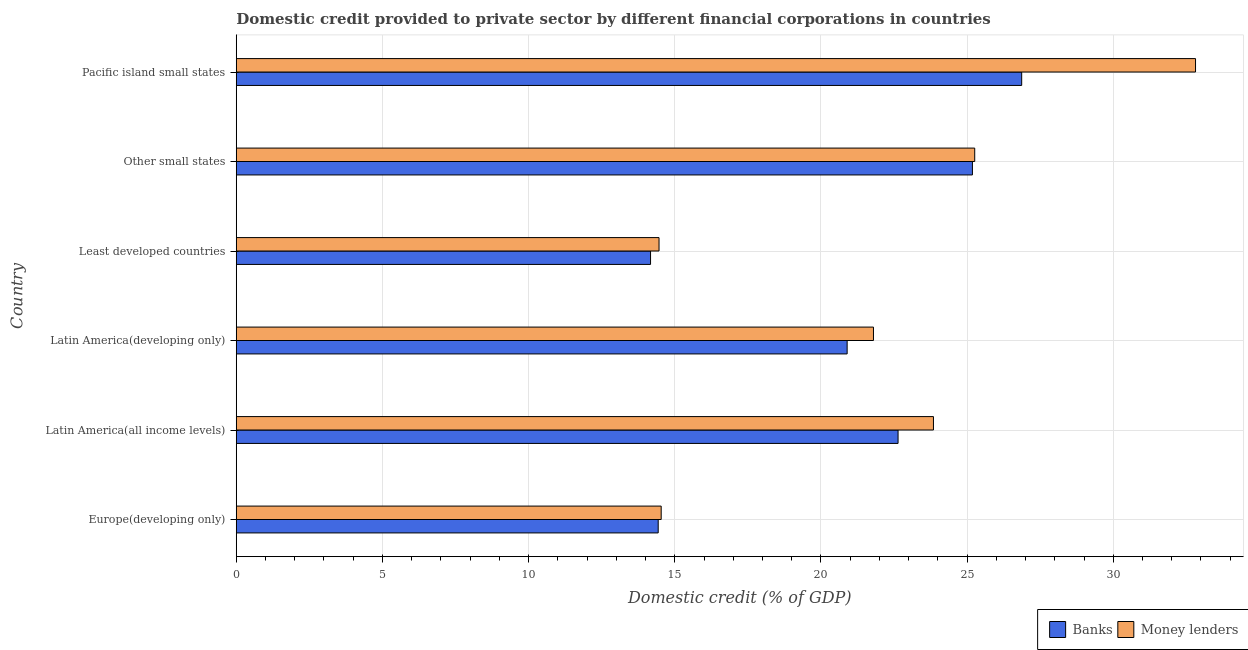How many different coloured bars are there?
Make the answer very short. 2. How many groups of bars are there?
Give a very brief answer. 6. Are the number of bars on each tick of the Y-axis equal?
Ensure brevity in your answer.  Yes. How many bars are there on the 3rd tick from the top?
Offer a very short reply. 2. What is the label of the 4th group of bars from the top?
Your answer should be very brief. Latin America(developing only). What is the domestic credit provided by banks in Latin America(developing only)?
Provide a succinct answer. 20.9. Across all countries, what is the maximum domestic credit provided by banks?
Your answer should be very brief. 26.87. Across all countries, what is the minimum domestic credit provided by banks?
Make the answer very short. 14.17. In which country was the domestic credit provided by money lenders maximum?
Ensure brevity in your answer.  Pacific island small states. In which country was the domestic credit provided by banks minimum?
Offer a very short reply. Least developed countries. What is the total domestic credit provided by banks in the graph?
Keep it short and to the point. 124.19. What is the difference between the domestic credit provided by money lenders in Other small states and that in Pacific island small states?
Offer a terse response. -7.55. What is the difference between the domestic credit provided by money lenders in Pacific island small states and the domestic credit provided by banks in Latin America(all income levels)?
Provide a short and direct response. 10.18. What is the average domestic credit provided by money lenders per country?
Offer a very short reply. 22.12. What is the difference between the domestic credit provided by money lenders and domestic credit provided by banks in Other small states?
Provide a short and direct response. 0.08. What is the ratio of the domestic credit provided by banks in Latin America(all income levels) to that in Pacific island small states?
Offer a very short reply. 0.84. Is the difference between the domestic credit provided by money lenders in Europe(developing only) and Latin America(developing only) greater than the difference between the domestic credit provided by banks in Europe(developing only) and Latin America(developing only)?
Keep it short and to the point. No. What is the difference between the highest and the second highest domestic credit provided by money lenders?
Give a very brief answer. 7.55. What is the difference between the highest and the lowest domestic credit provided by money lenders?
Give a very brief answer. 18.35. Is the sum of the domestic credit provided by banks in Europe(developing only) and Least developed countries greater than the maximum domestic credit provided by money lenders across all countries?
Your answer should be very brief. No. What does the 2nd bar from the top in Least developed countries represents?
Keep it short and to the point. Banks. What does the 2nd bar from the bottom in Latin America(all income levels) represents?
Your answer should be very brief. Money lenders. How many bars are there?
Your answer should be compact. 12. How many countries are there in the graph?
Your answer should be compact. 6. What is the title of the graph?
Make the answer very short. Domestic credit provided to private sector by different financial corporations in countries. What is the label or title of the X-axis?
Ensure brevity in your answer.  Domestic credit (% of GDP). What is the Domestic credit (% of GDP) of Banks in Europe(developing only)?
Your answer should be very brief. 14.43. What is the Domestic credit (% of GDP) of Money lenders in Europe(developing only)?
Ensure brevity in your answer.  14.54. What is the Domestic credit (% of GDP) in Banks in Latin America(all income levels)?
Give a very brief answer. 22.64. What is the Domestic credit (% of GDP) of Money lenders in Latin America(all income levels)?
Make the answer very short. 23.85. What is the Domestic credit (% of GDP) in Banks in Latin America(developing only)?
Provide a succinct answer. 20.9. What is the Domestic credit (% of GDP) in Money lenders in Latin America(developing only)?
Keep it short and to the point. 21.8. What is the Domestic credit (% of GDP) of Banks in Least developed countries?
Your answer should be very brief. 14.17. What is the Domestic credit (% of GDP) in Money lenders in Least developed countries?
Make the answer very short. 14.46. What is the Domestic credit (% of GDP) in Banks in Other small states?
Offer a very short reply. 25.18. What is the Domestic credit (% of GDP) in Money lenders in Other small states?
Keep it short and to the point. 25.26. What is the Domestic credit (% of GDP) of Banks in Pacific island small states?
Give a very brief answer. 26.87. What is the Domestic credit (% of GDP) of Money lenders in Pacific island small states?
Provide a short and direct response. 32.81. Across all countries, what is the maximum Domestic credit (% of GDP) of Banks?
Your answer should be very brief. 26.87. Across all countries, what is the maximum Domestic credit (% of GDP) of Money lenders?
Keep it short and to the point. 32.81. Across all countries, what is the minimum Domestic credit (% of GDP) of Banks?
Provide a short and direct response. 14.17. Across all countries, what is the minimum Domestic credit (% of GDP) in Money lenders?
Make the answer very short. 14.46. What is the total Domestic credit (% of GDP) in Banks in the graph?
Give a very brief answer. 124.19. What is the total Domestic credit (% of GDP) of Money lenders in the graph?
Your response must be concise. 132.72. What is the difference between the Domestic credit (% of GDP) of Banks in Europe(developing only) and that in Latin America(all income levels)?
Keep it short and to the point. -8.21. What is the difference between the Domestic credit (% of GDP) in Money lenders in Europe(developing only) and that in Latin America(all income levels)?
Offer a terse response. -9.31. What is the difference between the Domestic credit (% of GDP) in Banks in Europe(developing only) and that in Latin America(developing only)?
Make the answer very short. -6.46. What is the difference between the Domestic credit (% of GDP) of Money lenders in Europe(developing only) and that in Latin America(developing only)?
Your answer should be very brief. -7.26. What is the difference between the Domestic credit (% of GDP) of Banks in Europe(developing only) and that in Least developed countries?
Provide a succinct answer. 0.26. What is the difference between the Domestic credit (% of GDP) in Money lenders in Europe(developing only) and that in Least developed countries?
Ensure brevity in your answer.  0.07. What is the difference between the Domestic credit (% of GDP) of Banks in Europe(developing only) and that in Other small states?
Ensure brevity in your answer.  -10.75. What is the difference between the Domestic credit (% of GDP) in Money lenders in Europe(developing only) and that in Other small states?
Provide a short and direct response. -10.73. What is the difference between the Domestic credit (% of GDP) of Banks in Europe(developing only) and that in Pacific island small states?
Your answer should be very brief. -12.43. What is the difference between the Domestic credit (% of GDP) of Money lenders in Europe(developing only) and that in Pacific island small states?
Your answer should be compact. -18.28. What is the difference between the Domestic credit (% of GDP) in Banks in Latin America(all income levels) and that in Latin America(developing only)?
Ensure brevity in your answer.  1.74. What is the difference between the Domestic credit (% of GDP) of Money lenders in Latin America(all income levels) and that in Latin America(developing only)?
Ensure brevity in your answer.  2.05. What is the difference between the Domestic credit (% of GDP) in Banks in Latin America(all income levels) and that in Least developed countries?
Your answer should be compact. 8.47. What is the difference between the Domestic credit (% of GDP) in Money lenders in Latin America(all income levels) and that in Least developed countries?
Provide a succinct answer. 9.39. What is the difference between the Domestic credit (% of GDP) in Banks in Latin America(all income levels) and that in Other small states?
Keep it short and to the point. -2.54. What is the difference between the Domestic credit (% of GDP) in Money lenders in Latin America(all income levels) and that in Other small states?
Provide a succinct answer. -1.41. What is the difference between the Domestic credit (% of GDP) of Banks in Latin America(all income levels) and that in Pacific island small states?
Provide a succinct answer. -4.23. What is the difference between the Domestic credit (% of GDP) in Money lenders in Latin America(all income levels) and that in Pacific island small states?
Provide a succinct answer. -8.96. What is the difference between the Domestic credit (% of GDP) of Banks in Latin America(developing only) and that in Least developed countries?
Provide a short and direct response. 6.73. What is the difference between the Domestic credit (% of GDP) in Money lenders in Latin America(developing only) and that in Least developed countries?
Provide a short and direct response. 7.34. What is the difference between the Domestic credit (% of GDP) in Banks in Latin America(developing only) and that in Other small states?
Your answer should be very brief. -4.29. What is the difference between the Domestic credit (% of GDP) of Money lenders in Latin America(developing only) and that in Other small states?
Provide a succinct answer. -3.46. What is the difference between the Domestic credit (% of GDP) in Banks in Latin America(developing only) and that in Pacific island small states?
Offer a very short reply. -5.97. What is the difference between the Domestic credit (% of GDP) of Money lenders in Latin America(developing only) and that in Pacific island small states?
Ensure brevity in your answer.  -11.02. What is the difference between the Domestic credit (% of GDP) of Banks in Least developed countries and that in Other small states?
Ensure brevity in your answer.  -11.01. What is the difference between the Domestic credit (% of GDP) of Money lenders in Least developed countries and that in Other small states?
Provide a short and direct response. -10.8. What is the difference between the Domestic credit (% of GDP) of Banks in Least developed countries and that in Pacific island small states?
Your answer should be very brief. -12.7. What is the difference between the Domestic credit (% of GDP) of Money lenders in Least developed countries and that in Pacific island small states?
Your answer should be compact. -18.35. What is the difference between the Domestic credit (% of GDP) in Banks in Other small states and that in Pacific island small states?
Your answer should be very brief. -1.69. What is the difference between the Domestic credit (% of GDP) of Money lenders in Other small states and that in Pacific island small states?
Your answer should be very brief. -7.55. What is the difference between the Domestic credit (% of GDP) in Banks in Europe(developing only) and the Domestic credit (% of GDP) in Money lenders in Latin America(all income levels)?
Ensure brevity in your answer.  -9.42. What is the difference between the Domestic credit (% of GDP) of Banks in Europe(developing only) and the Domestic credit (% of GDP) of Money lenders in Latin America(developing only)?
Provide a succinct answer. -7.36. What is the difference between the Domestic credit (% of GDP) of Banks in Europe(developing only) and the Domestic credit (% of GDP) of Money lenders in Least developed countries?
Keep it short and to the point. -0.03. What is the difference between the Domestic credit (% of GDP) of Banks in Europe(developing only) and the Domestic credit (% of GDP) of Money lenders in Other small states?
Make the answer very short. -10.83. What is the difference between the Domestic credit (% of GDP) in Banks in Europe(developing only) and the Domestic credit (% of GDP) in Money lenders in Pacific island small states?
Make the answer very short. -18.38. What is the difference between the Domestic credit (% of GDP) of Banks in Latin America(all income levels) and the Domestic credit (% of GDP) of Money lenders in Latin America(developing only)?
Give a very brief answer. 0.84. What is the difference between the Domestic credit (% of GDP) in Banks in Latin America(all income levels) and the Domestic credit (% of GDP) in Money lenders in Least developed countries?
Offer a very short reply. 8.18. What is the difference between the Domestic credit (% of GDP) of Banks in Latin America(all income levels) and the Domestic credit (% of GDP) of Money lenders in Other small states?
Your answer should be very brief. -2.62. What is the difference between the Domestic credit (% of GDP) of Banks in Latin America(all income levels) and the Domestic credit (% of GDP) of Money lenders in Pacific island small states?
Give a very brief answer. -10.18. What is the difference between the Domestic credit (% of GDP) of Banks in Latin America(developing only) and the Domestic credit (% of GDP) of Money lenders in Least developed countries?
Offer a very short reply. 6.43. What is the difference between the Domestic credit (% of GDP) in Banks in Latin America(developing only) and the Domestic credit (% of GDP) in Money lenders in Other small states?
Give a very brief answer. -4.36. What is the difference between the Domestic credit (% of GDP) of Banks in Latin America(developing only) and the Domestic credit (% of GDP) of Money lenders in Pacific island small states?
Keep it short and to the point. -11.92. What is the difference between the Domestic credit (% of GDP) in Banks in Least developed countries and the Domestic credit (% of GDP) in Money lenders in Other small states?
Your answer should be compact. -11.09. What is the difference between the Domestic credit (% of GDP) of Banks in Least developed countries and the Domestic credit (% of GDP) of Money lenders in Pacific island small states?
Offer a terse response. -18.64. What is the difference between the Domestic credit (% of GDP) in Banks in Other small states and the Domestic credit (% of GDP) in Money lenders in Pacific island small states?
Offer a very short reply. -7.63. What is the average Domestic credit (% of GDP) of Banks per country?
Offer a very short reply. 20.7. What is the average Domestic credit (% of GDP) in Money lenders per country?
Provide a short and direct response. 22.12. What is the difference between the Domestic credit (% of GDP) of Banks and Domestic credit (% of GDP) of Money lenders in Europe(developing only)?
Your answer should be very brief. -0.1. What is the difference between the Domestic credit (% of GDP) in Banks and Domestic credit (% of GDP) in Money lenders in Latin America(all income levels)?
Your answer should be very brief. -1.21. What is the difference between the Domestic credit (% of GDP) of Banks and Domestic credit (% of GDP) of Money lenders in Latin America(developing only)?
Make the answer very short. -0.9. What is the difference between the Domestic credit (% of GDP) of Banks and Domestic credit (% of GDP) of Money lenders in Least developed countries?
Make the answer very short. -0.29. What is the difference between the Domestic credit (% of GDP) in Banks and Domestic credit (% of GDP) in Money lenders in Other small states?
Make the answer very short. -0.08. What is the difference between the Domestic credit (% of GDP) in Banks and Domestic credit (% of GDP) in Money lenders in Pacific island small states?
Your response must be concise. -5.95. What is the ratio of the Domestic credit (% of GDP) in Banks in Europe(developing only) to that in Latin America(all income levels)?
Your response must be concise. 0.64. What is the ratio of the Domestic credit (% of GDP) in Money lenders in Europe(developing only) to that in Latin America(all income levels)?
Your answer should be very brief. 0.61. What is the ratio of the Domestic credit (% of GDP) in Banks in Europe(developing only) to that in Latin America(developing only)?
Offer a terse response. 0.69. What is the ratio of the Domestic credit (% of GDP) in Money lenders in Europe(developing only) to that in Latin America(developing only)?
Make the answer very short. 0.67. What is the ratio of the Domestic credit (% of GDP) in Banks in Europe(developing only) to that in Least developed countries?
Ensure brevity in your answer.  1.02. What is the ratio of the Domestic credit (% of GDP) of Banks in Europe(developing only) to that in Other small states?
Give a very brief answer. 0.57. What is the ratio of the Domestic credit (% of GDP) in Money lenders in Europe(developing only) to that in Other small states?
Keep it short and to the point. 0.58. What is the ratio of the Domestic credit (% of GDP) of Banks in Europe(developing only) to that in Pacific island small states?
Your response must be concise. 0.54. What is the ratio of the Domestic credit (% of GDP) of Money lenders in Europe(developing only) to that in Pacific island small states?
Your answer should be compact. 0.44. What is the ratio of the Domestic credit (% of GDP) of Banks in Latin America(all income levels) to that in Latin America(developing only)?
Provide a succinct answer. 1.08. What is the ratio of the Domestic credit (% of GDP) of Money lenders in Latin America(all income levels) to that in Latin America(developing only)?
Keep it short and to the point. 1.09. What is the ratio of the Domestic credit (% of GDP) in Banks in Latin America(all income levels) to that in Least developed countries?
Make the answer very short. 1.6. What is the ratio of the Domestic credit (% of GDP) in Money lenders in Latin America(all income levels) to that in Least developed countries?
Offer a terse response. 1.65. What is the ratio of the Domestic credit (% of GDP) in Banks in Latin America(all income levels) to that in Other small states?
Keep it short and to the point. 0.9. What is the ratio of the Domestic credit (% of GDP) of Money lenders in Latin America(all income levels) to that in Other small states?
Keep it short and to the point. 0.94. What is the ratio of the Domestic credit (% of GDP) of Banks in Latin America(all income levels) to that in Pacific island small states?
Give a very brief answer. 0.84. What is the ratio of the Domestic credit (% of GDP) of Money lenders in Latin America(all income levels) to that in Pacific island small states?
Your response must be concise. 0.73. What is the ratio of the Domestic credit (% of GDP) in Banks in Latin America(developing only) to that in Least developed countries?
Make the answer very short. 1.47. What is the ratio of the Domestic credit (% of GDP) in Money lenders in Latin America(developing only) to that in Least developed countries?
Make the answer very short. 1.51. What is the ratio of the Domestic credit (% of GDP) in Banks in Latin America(developing only) to that in Other small states?
Keep it short and to the point. 0.83. What is the ratio of the Domestic credit (% of GDP) of Money lenders in Latin America(developing only) to that in Other small states?
Provide a short and direct response. 0.86. What is the ratio of the Domestic credit (% of GDP) of Money lenders in Latin America(developing only) to that in Pacific island small states?
Ensure brevity in your answer.  0.66. What is the ratio of the Domestic credit (% of GDP) of Banks in Least developed countries to that in Other small states?
Offer a terse response. 0.56. What is the ratio of the Domestic credit (% of GDP) of Money lenders in Least developed countries to that in Other small states?
Provide a succinct answer. 0.57. What is the ratio of the Domestic credit (% of GDP) of Banks in Least developed countries to that in Pacific island small states?
Keep it short and to the point. 0.53. What is the ratio of the Domestic credit (% of GDP) in Money lenders in Least developed countries to that in Pacific island small states?
Provide a short and direct response. 0.44. What is the ratio of the Domestic credit (% of GDP) in Banks in Other small states to that in Pacific island small states?
Your response must be concise. 0.94. What is the ratio of the Domestic credit (% of GDP) in Money lenders in Other small states to that in Pacific island small states?
Your answer should be compact. 0.77. What is the difference between the highest and the second highest Domestic credit (% of GDP) in Banks?
Offer a very short reply. 1.69. What is the difference between the highest and the second highest Domestic credit (% of GDP) of Money lenders?
Provide a short and direct response. 7.55. What is the difference between the highest and the lowest Domestic credit (% of GDP) in Banks?
Your response must be concise. 12.7. What is the difference between the highest and the lowest Domestic credit (% of GDP) in Money lenders?
Give a very brief answer. 18.35. 